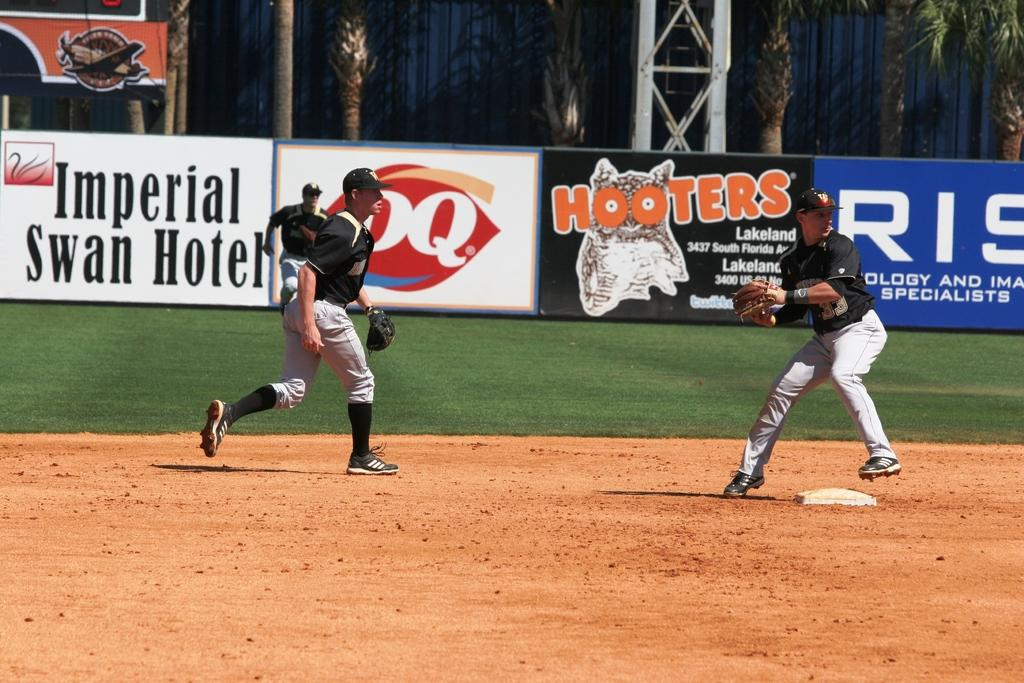<image>
Render a clear and concise summary of the photo. Baseball players playing in front of an ad for Hooters. 